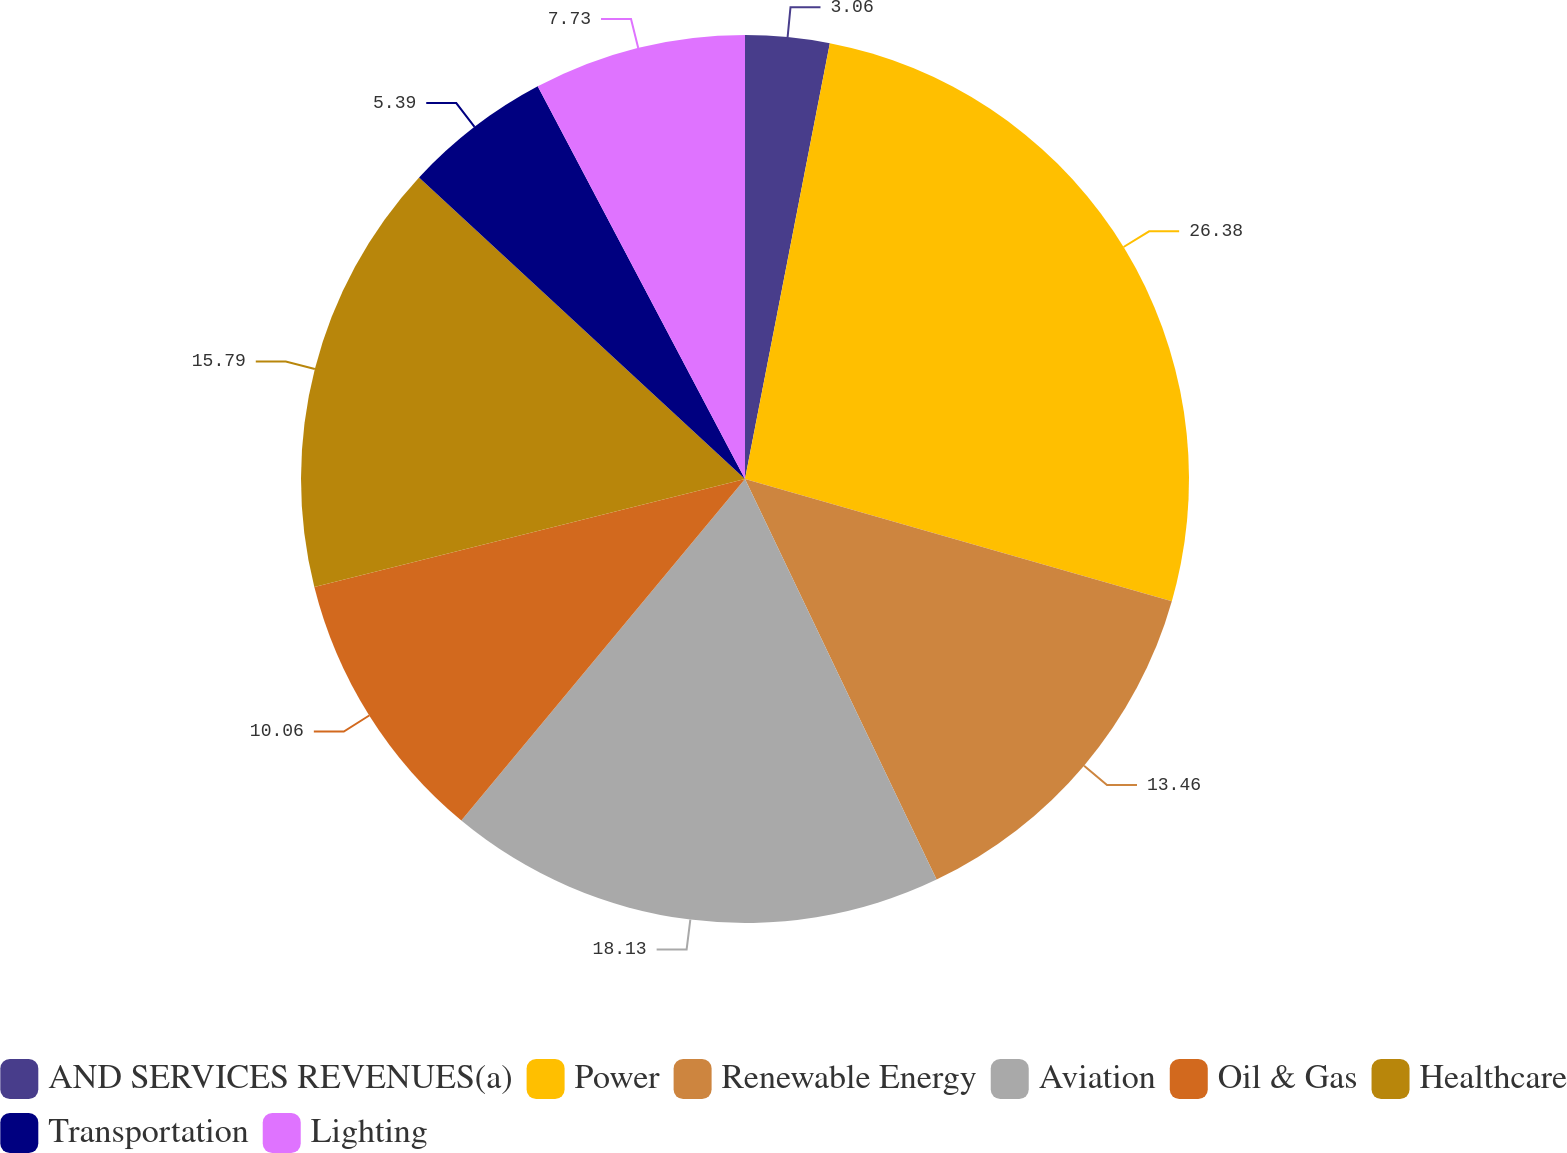Convert chart to OTSL. <chart><loc_0><loc_0><loc_500><loc_500><pie_chart><fcel>AND SERVICES REVENUES(a)<fcel>Power<fcel>Renewable Energy<fcel>Aviation<fcel>Oil & Gas<fcel>Healthcare<fcel>Transportation<fcel>Lighting<nl><fcel>3.06%<fcel>26.38%<fcel>13.46%<fcel>18.13%<fcel>10.06%<fcel>15.79%<fcel>5.39%<fcel>7.73%<nl></chart> 